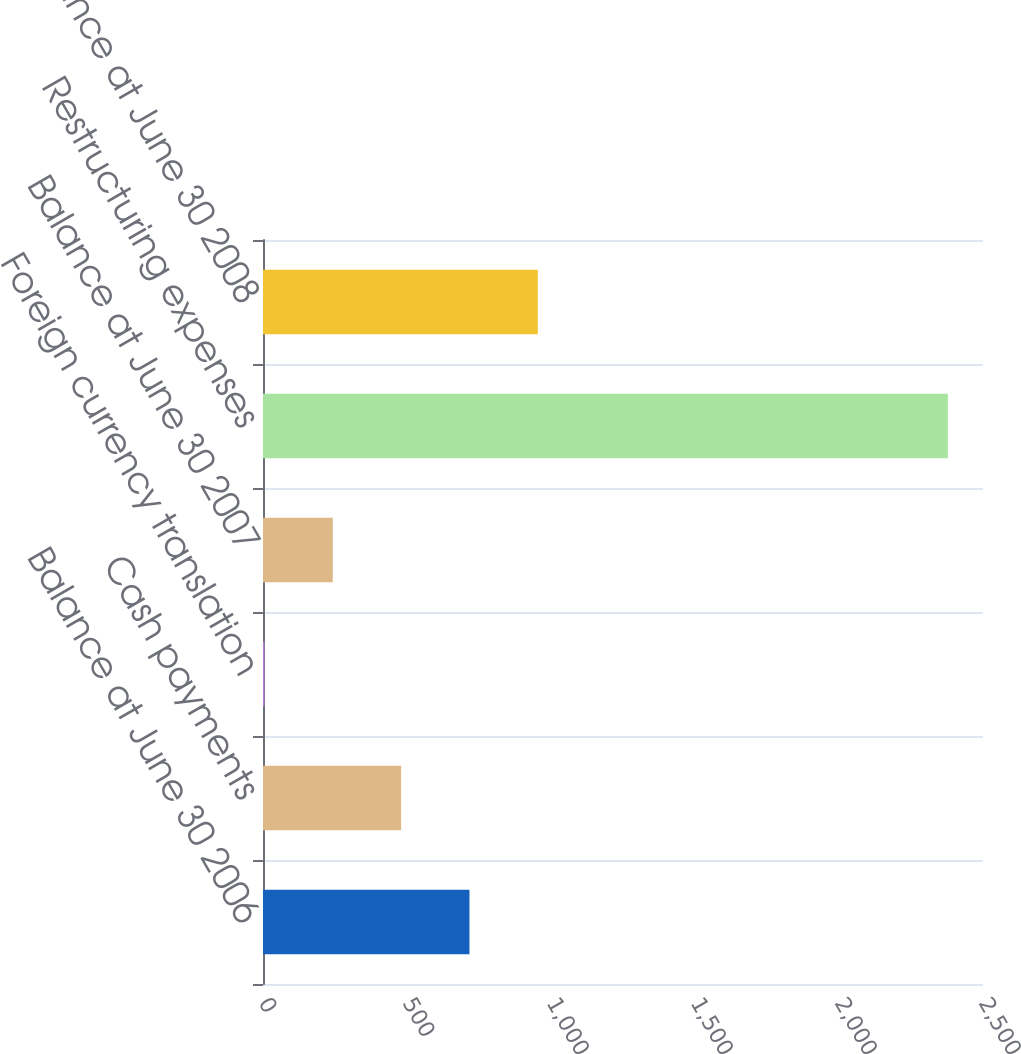Convert chart. <chart><loc_0><loc_0><loc_500><loc_500><bar_chart><fcel>Balance at June 30 2006<fcel>Cash payments<fcel>Foreign currency translation<fcel>Balance at June 30 2007<fcel>Restructuring expenses<fcel>Balance at June 30 2008<nl><fcel>716.9<fcel>479.6<fcel>5<fcel>242.3<fcel>2378<fcel>954.2<nl></chart> 